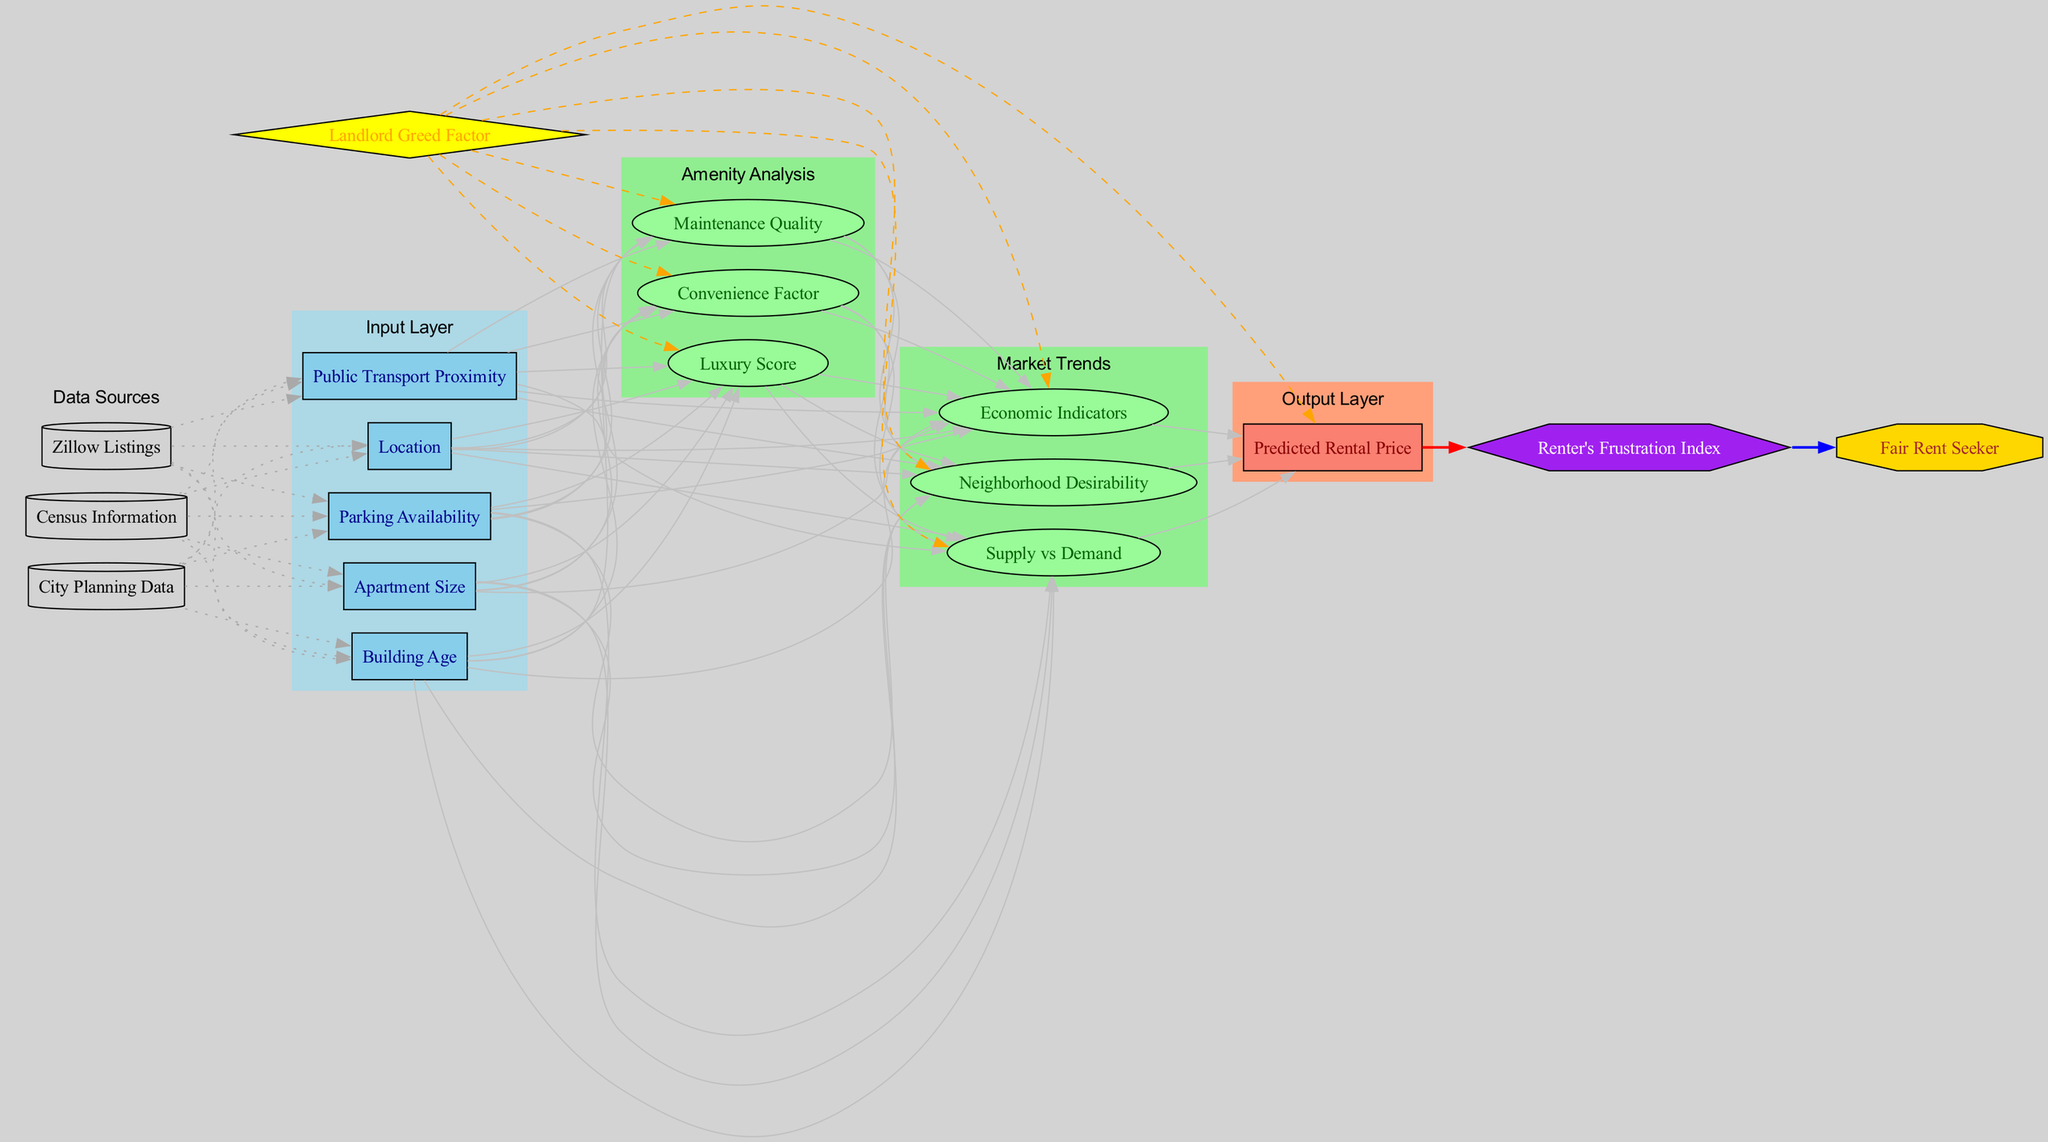What are the input nodes in this neural network? The input nodes listed in the diagram are "Apartment Size", "Location", "Building Age", "Public Transport Proximity", and "Parking Availability." These nodes are fundamental to the analysis of rental prices.
Answer: Apartment Size, Location, Building Age, Public Transport Proximity, Parking Availability How many hidden layers are present in the diagram? The diagram contains two hidden layers: "Amenity Analysis" and "Market Trends." This count is derived directly from the structure of the diagram.
Answer: 2 What is the output node of this neural network? The output node is "Predicted Rental Price," which represents the result of the neural network's processing of the inputs through the hidden layers.
Answer: Predicted Rental Price What is the bias node in this diagram? The bias node is "Landlord Greed Factor." It influences all nodes in the hidden layers and output layer, as depicted by the dashed connections.
Answer: Landlord Greed Factor Which data source is used for the input layer? The input layer receives data from sources such as "Zillow Listings", "City Planning Data", and "Census Information." These sources provide essential data for the inputs.
Answer: Zillow Listings, City Planning Data, Census Information How does the loss function relate to the output node? The loss function "Renter's Frustration Index" connects directly to the output node "Predicted Rental Price." This means the predicted price influences the frustration index, which assesses the outcome quality.
Answer: Renter's Frustration Index What are the three nodes in the "Amenity Analysis" hidden layer? The nodes in the "Amenity Analysis" layer are "Luxury Score", "Convenience Factor", and "Maintenance Quality." These nodes evaluate various aspects of amenities that can impact rental pricing.
Answer: Luxury Score, Convenience Factor, Maintenance Quality Which optimization algorithm is used in this neural network? The optimization algorithm used is "Fair Rent Seeker," which suggests a focus on achieving fair rental prices based on analysis outcomes.
Answer: Fair Rent Seeker What type of connections are shown from the bias node to the layers? The connections from the bias node to the hidden layers and output layer are dashed, indicating a bias influence rather than direct input. This separation highlights its role in adjusting outputs rather than acting as data itself.
Answer: Dashed connections 